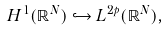Convert formula to latex. <formula><loc_0><loc_0><loc_500><loc_500>H ^ { 1 } ( \mathbb { R } ^ { N } ) \hookrightarrow L ^ { 2 p } ( \mathbb { R } ^ { N } ) ,</formula> 